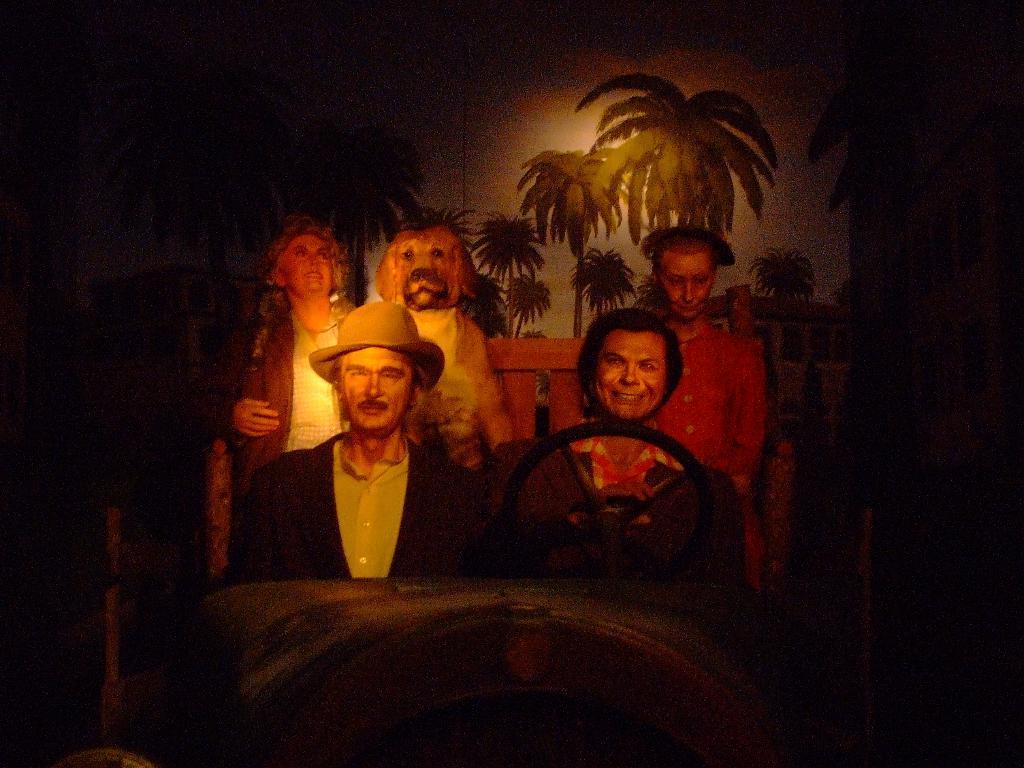Describe this image in one or two sentences. In this picture we can see trees and people. It seems like a dog. This is a picture of painting. 